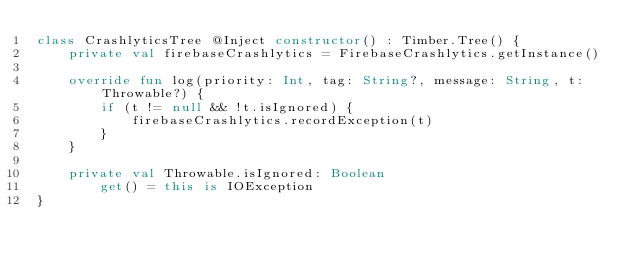Convert code to text. <code><loc_0><loc_0><loc_500><loc_500><_Kotlin_>class CrashlyticsTree @Inject constructor() : Timber.Tree() {
    private val firebaseCrashlytics = FirebaseCrashlytics.getInstance()

    override fun log(priority: Int, tag: String?, message: String, t: Throwable?) {
        if (t != null && !t.isIgnored) {
            firebaseCrashlytics.recordException(t)
        }
    }

    private val Throwable.isIgnored: Boolean
        get() = this is IOException
}
</code> 